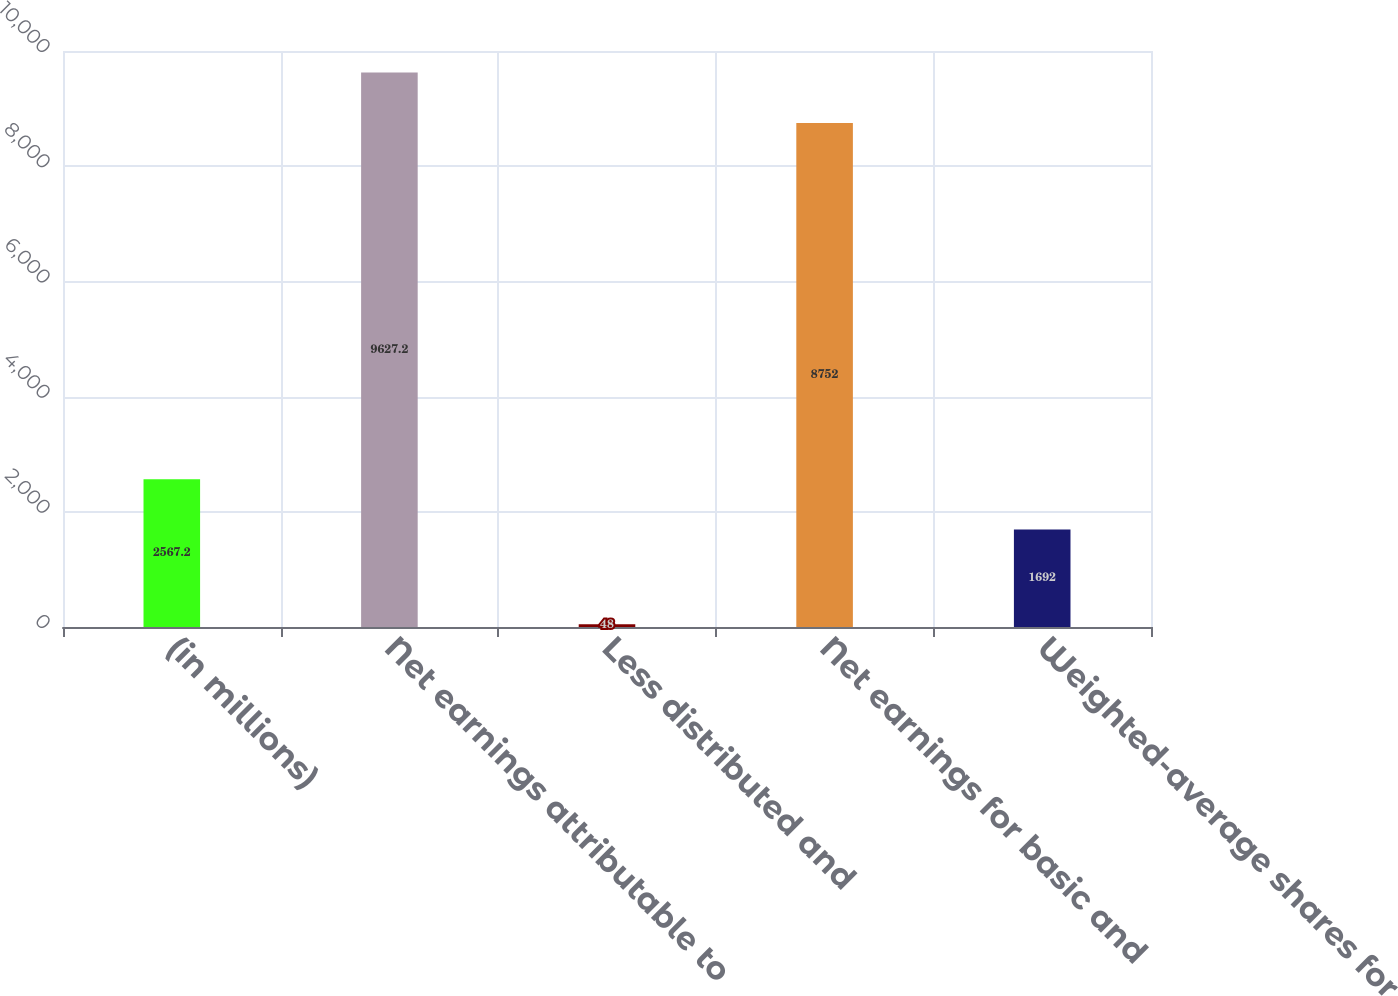Convert chart to OTSL. <chart><loc_0><loc_0><loc_500><loc_500><bar_chart><fcel>(in millions)<fcel>Net earnings attributable to<fcel>Less distributed and<fcel>Net earnings for basic and<fcel>Weighted-average shares for<nl><fcel>2567.2<fcel>9627.2<fcel>48<fcel>8752<fcel>1692<nl></chart> 